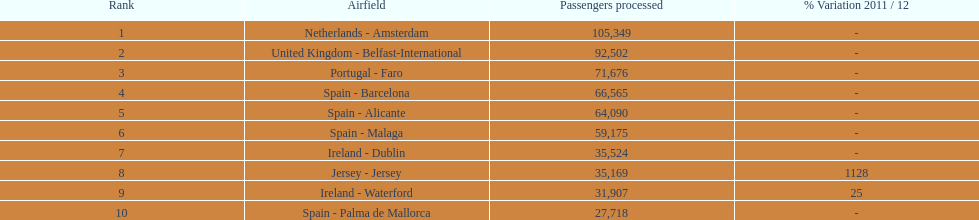How many airports are listed? 10. 